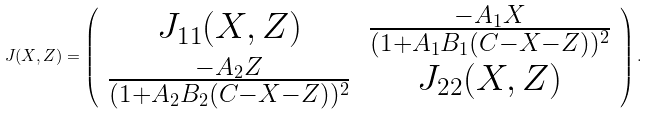<formula> <loc_0><loc_0><loc_500><loc_500>J ( X , Z ) = \left ( \begin{array} { c c } J _ { 1 1 } ( X , Z ) & \frac { - A _ { 1 } X } { ( 1 + A _ { 1 } B _ { 1 } ( C - X - Z ) ) ^ { 2 } } \\ \frac { - A _ { 2 } Z } { ( 1 + A _ { 2 } B _ { 2 } ( C - X - Z ) ) ^ { 2 } } & J _ { 2 2 } ( X , Z ) \end{array} \right ) .</formula> 